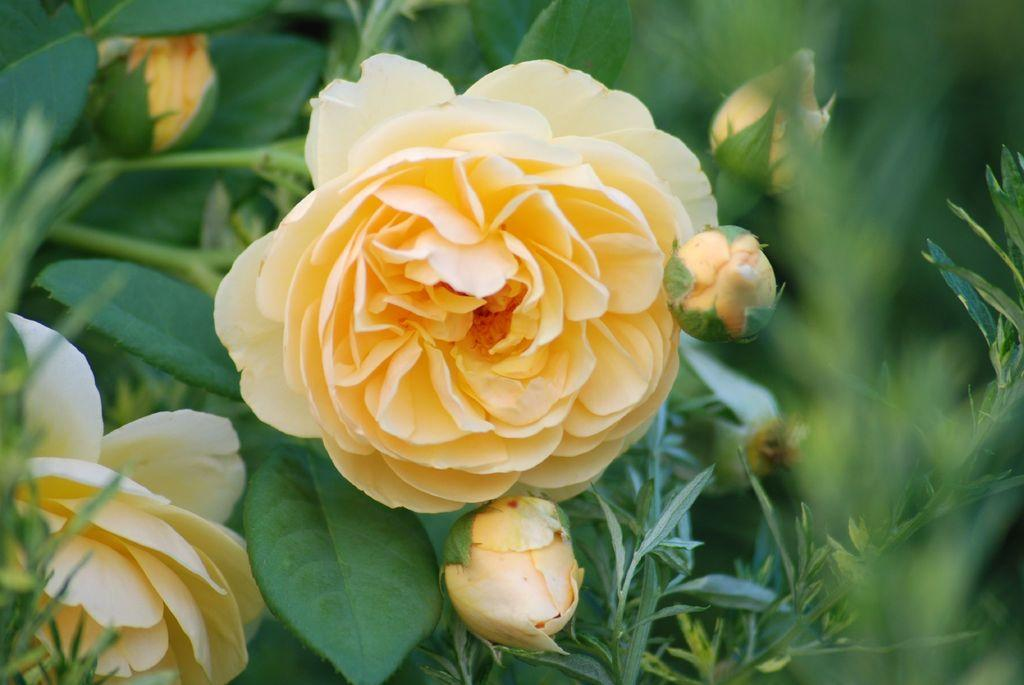What type of flowers are present in the image? There are roses in the image. What stage of growth are some of the flowers in? There are buds in the image. What color are the leaves in the image? The leaves in the image are green. What type of music is being played by the servant in the image? There is no servant or music present in the image; it features roses, buds, and green leaves. 